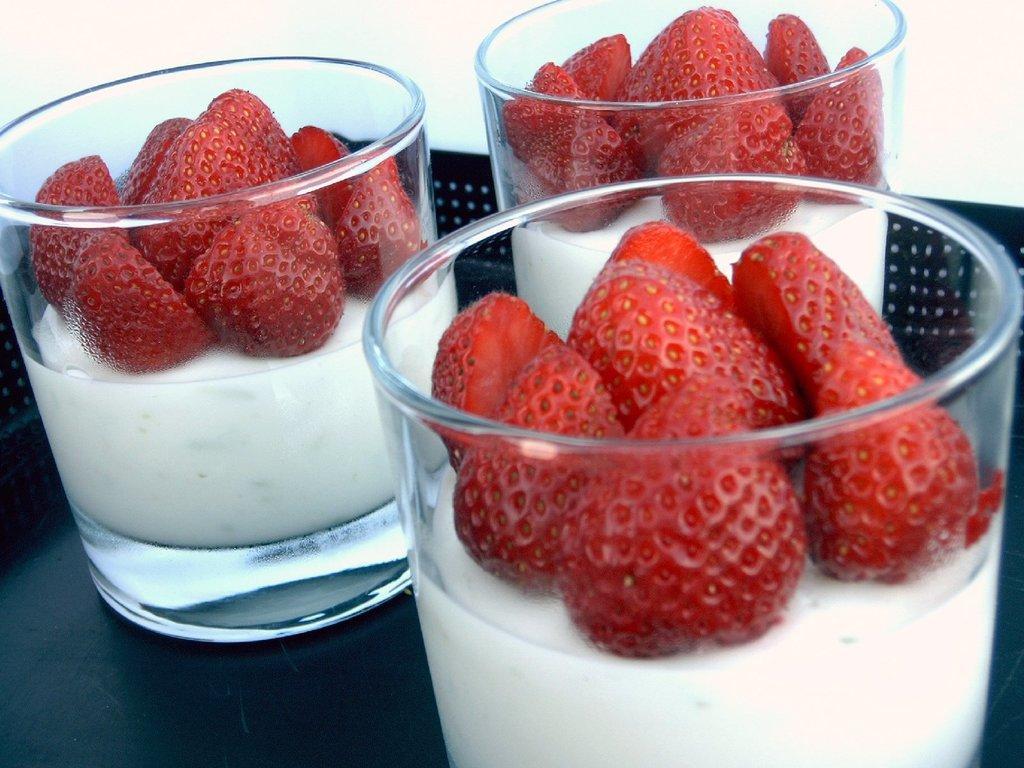Could you give a brief overview of what you see in this image? In this picture there are glasses, strawberries and a drink. The glasses are placed on a black surface. 